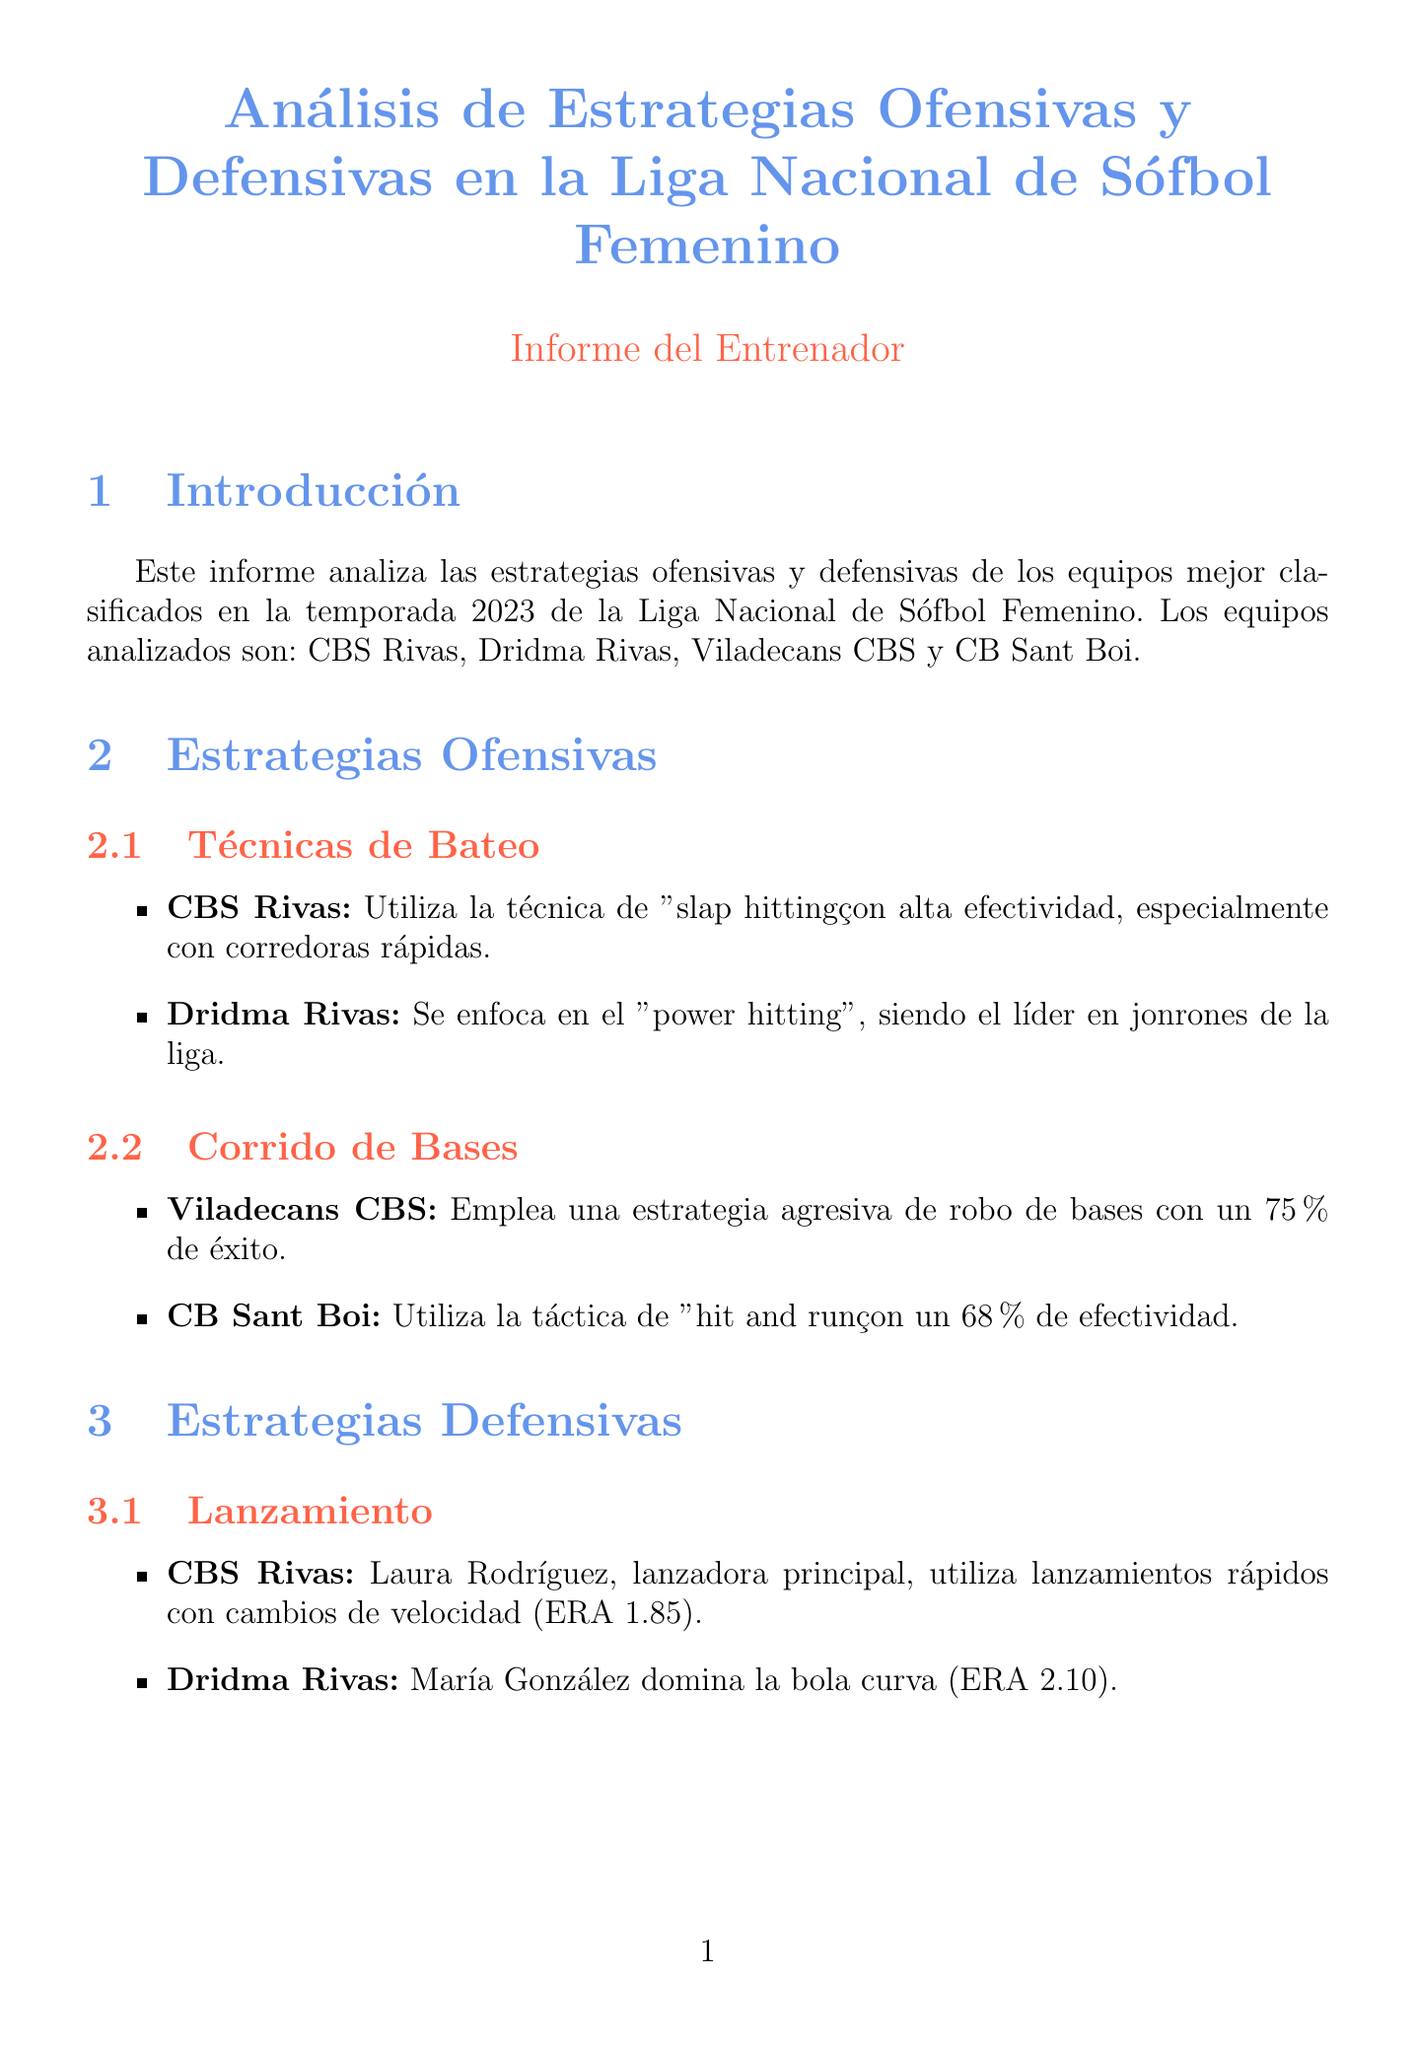What teams are analyzed in the report? The teams analyzed in the report are listed in the introduction section.
Answer: CBS Rivas, Dridma Rivas, Viladecans CBS, CB Sant Boi What batting technique does CBS Rivas use? The batting technique used by CBS Rivas is mentioned in the offensive strategies section.
Answer: Slap hitting What is the effectiveness rate of Viladecans CBS's base running strategy? The success rate of Viladecans CBS's base running strategy is stated in the document.
Answer: 75% Who is the primary pitcher for Dridma Rivas? The primary pitcher for Dridma Rivas is identified in the defensive strategies section.
Answer: María González What is the ERA of CBS Rivas? The ERA of CBS Rivas is part of the statistical comparison presented in the document.
Answer: 2.15 Which team has the highest batting average? The team's batting averages are provided in the statistical comparison.
Answer: CBS Rivas What formation does CB Sant Boi use in fielding? The fielding formation of CB Sant Boi is detailed in the defensive strategies section.
Answer: Outfield jugando cerca What is the offensive contribution of Elena Martínez? Elena Martínez's offensive contribution is specified in the key players section.
Answer: Líder en hits de la liga What is the summary of the conclusion? The conclusion summary encapsulates the findings of the report.
Answer: CBS Rivas y Dridma Rivas muestran un equilibrio superior entre ofensiva y defensiva 